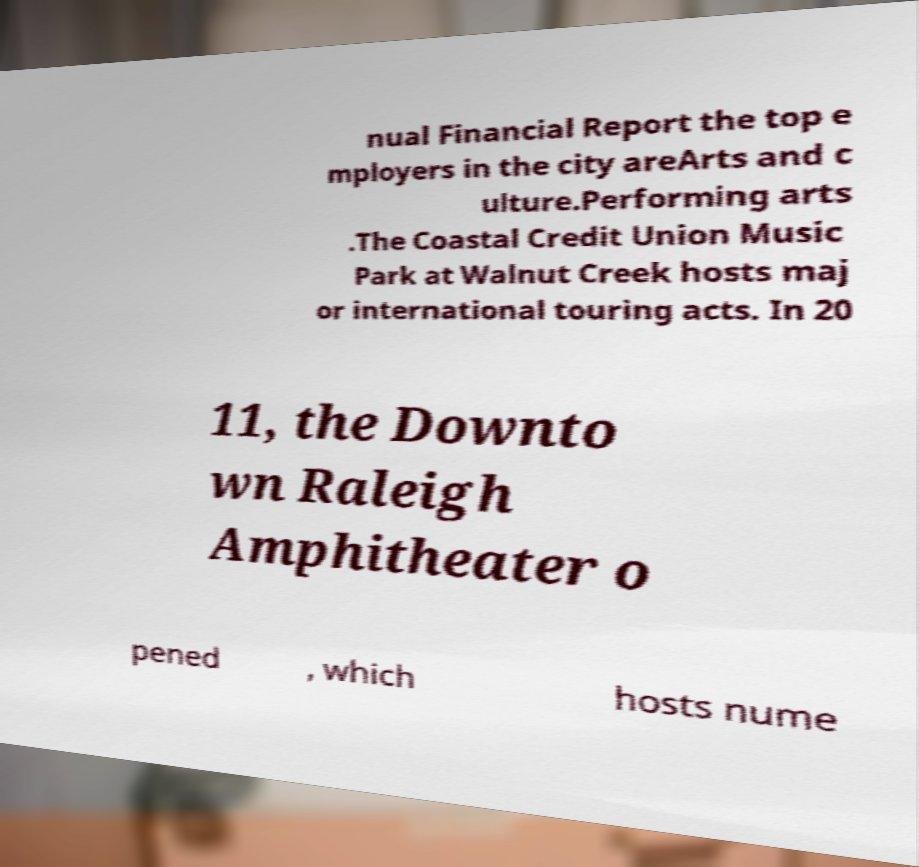For documentation purposes, I need the text within this image transcribed. Could you provide that? nual Financial Report the top e mployers in the city areArts and c ulture.Performing arts .The Coastal Credit Union Music Park at Walnut Creek hosts maj or international touring acts. In 20 11, the Downto wn Raleigh Amphitheater o pened , which hosts nume 